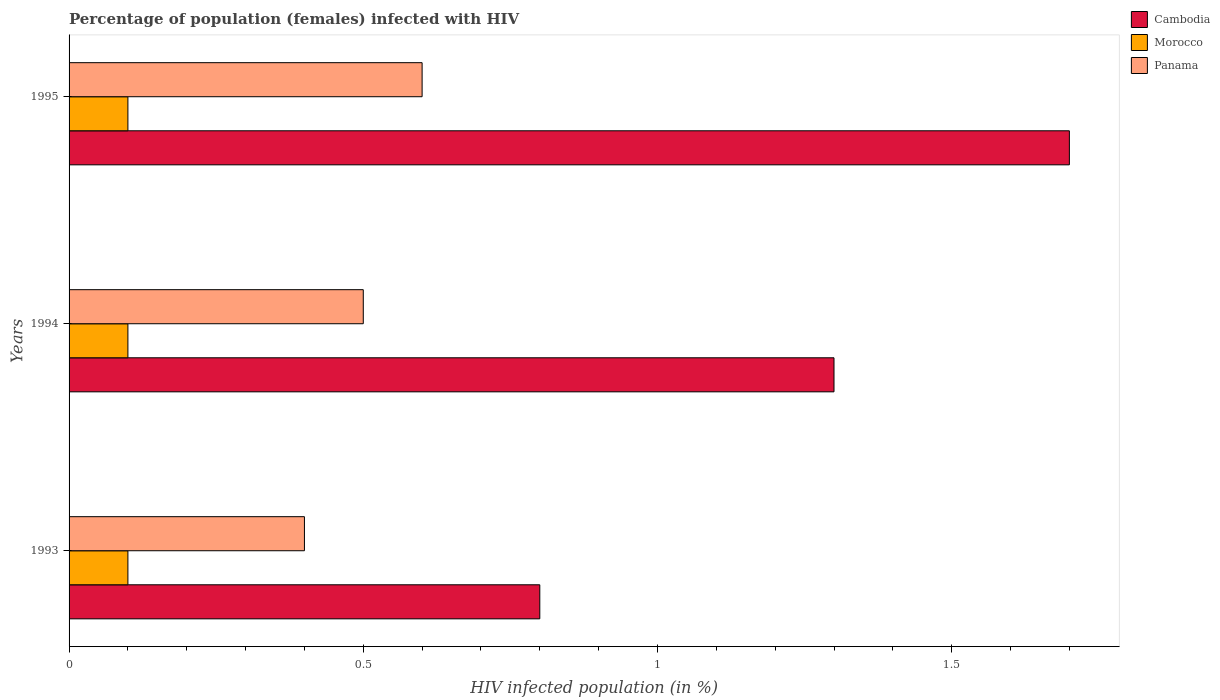How many different coloured bars are there?
Offer a very short reply. 3. Are the number of bars per tick equal to the number of legend labels?
Ensure brevity in your answer.  Yes. How many bars are there on the 2nd tick from the top?
Provide a succinct answer. 3. How many bars are there on the 2nd tick from the bottom?
Offer a terse response. 3. In which year was the percentage of HIV infected female population in Morocco maximum?
Ensure brevity in your answer.  1993. In which year was the percentage of HIV infected female population in Cambodia minimum?
Your response must be concise. 1993. What is the total percentage of HIV infected female population in Morocco in the graph?
Provide a succinct answer. 0.3. What is the difference between the percentage of HIV infected female population in Cambodia in 1993 and the percentage of HIV infected female population in Panama in 1995?
Provide a succinct answer. 0.2. What is the average percentage of HIV infected female population in Cambodia per year?
Give a very brief answer. 1.27. In the year 1994, what is the difference between the percentage of HIV infected female population in Panama and percentage of HIV infected female population in Morocco?
Offer a terse response. 0.4. In how many years, is the percentage of HIV infected female population in Cambodia greater than 0.5 %?
Give a very brief answer. 3. What is the ratio of the percentage of HIV infected female population in Cambodia in 1994 to that in 1995?
Make the answer very short. 0.76. Is the percentage of HIV infected female population in Morocco in 1993 less than that in 1994?
Keep it short and to the point. No. Is the difference between the percentage of HIV infected female population in Panama in 1993 and 1995 greater than the difference between the percentage of HIV infected female population in Morocco in 1993 and 1995?
Provide a short and direct response. No. What is the difference between the highest and the second highest percentage of HIV infected female population in Panama?
Provide a short and direct response. 0.1. What is the difference between the highest and the lowest percentage of HIV infected female population in Cambodia?
Provide a short and direct response. 0.9. Is the sum of the percentage of HIV infected female population in Panama in 1994 and 1995 greater than the maximum percentage of HIV infected female population in Cambodia across all years?
Your response must be concise. No. What does the 3rd bar from the top in 1995 represents?
Make the answer very short. Cambodia. What does the 3rd bar from the bottom in 1994 represents?
Provide a succinct answer. Panama. Is it the case that in every year, the sum of the percentage of HIV infected female population in Cambodia and percentage of HIV infected female population in Panama is greater than the percentage of HIV infected female population in Morocco?
Provide a succinct answer. Yes. What is the difference between two consecutive major ticks on the X-axis?
Your response must be concise. 0.5. Are the values on the major ticks of X-axis written in scientific E-notation?
Make the answer very short. No. Does the graph contain any zero values?
Offer a terse response. No. How many legend labels are there?
Your answer should be very brief. 3. What is the title of the graph?
Make the answer very short. Percentage of population (females) infected with HIV. Does "Bangladesh" appear as one of the legend labels in the graph?
Provide a short and direct response. No. What is the label or title of the X-axis?
Provide a short and direct response. HIV infected population (in %). What is the label or title of the Y-axis?
Your answer should be very brief. Years. What is the HIV infected population (in %) in Morocco in 1993?
Keep it short and to the point. 0.1. What is the HIV infected population (in %) in Cambodia in 1994?
Provide a short and direct response. 1.3. What is the HIV infected population (in %) of Panama in 1994?
Offer a terse response. 0.5. What is the HIV infected population (in %) in Panama in 1995?
Your answer should be very brief. 0.6. Across all years, what is the maximum HIV infected population (in %) of Cambodia?
Keep it short and to the point. 1.7. Across all years, what is the minimum HIV infected population (in %) of Cambodia?
Your answer should be very brief. 0.8. Across all years, what is the minimum HIV infected population (in %) of Morocco?
Provide a succinct answer. 0.1. What is the total HIV infected population (in %) in Cambodia in the graph?
Your answer should be compact. 3.8. What is the difference between the HIV infected population (in %) of Cambodia in 1993 and that in 1994?
Keep it short and to the point. -0.5. What is the difference between the HIV infected population (in %) of Panama in 1993 and that in 1995?
Give a very brief answer. -0.2. What is the difference between the HIV infected population (in %) in Morocco in 1994 and that in 1995?
Your response must be concise. 0. What is the difference between the HIV infected population (in %) in Panama in 1994 and that in 1995?
Offer a very short reply. -0.1. What is the difference between the HIV infected population (in %) in Cambodia in 1993 and the HIV infected population (in %) in Panama in 1995?
Provide a succinct answer. 0.2. What is the difference between the HIV infected population (in %) in Morocco in 1993 and the HIV infected population (in %) in Panama in 1995?
Keep it short and to the point. -0.5. What is the difference between the HIV infected population (in %) of Cambodia in 1994 and the HIV infected population (in %) of Morocco in 1995?
Provide a short and direct response. 1.2. What is the average HIV infected population (in %) in Cambodia per year?
Make the answer very short. 1.27. What is the average HIV infected population (in %) in Morocco per year?
Make the answer very short. 0.1. What is the average HIV infected population (in %) in Panama per year?
Give a very brief answer. 0.5. In the year 1993, what is the difference between the HIV infected population (in %) in Morocco and HIV infected population (in %) in Panama?
Offer a very short reply. -0.3. In the year 1995, what is the difference between the HIV infected population (in %) in Cambodia and HIV infected population (in %) in Panama?
Offer a terse response. 1.1. What is the ratio of the HIV infected population (in %) in Cambodia in 1993 to that in 1994?
Make the answer very short. 0.62. What is the ratio of the HIV infected population (in %) of Morocco in 1993 to that in 1994?
Make the answer very short. 1. What is the ratio of the HIV infected population (in %) in Panama in 1993 to that in 1994?
Make the answer very short. 0.8. What is the ratio of the HIV infected population (in %) of Cambodia in 1993 to that in 1995?
Your answer should be very brief. 0.47. What is the ratio of the HIV infected population (in %) of Morocco in 1993 to that in 1995?
Offer a very short reply. 1. What is the ratio of the HIV infected population (in %) in Panama in 1993 to that in 1995?
Make the answer very short. 0.67. What is the ratio of the HIV infected population (in %) of Cambodia in 1994 to that in 1995?
Offer a very short reply. 0.76. What is the ratio of the HIV infected population (in %) of Panama in 1994 to that in 1995?
Provide a succinct answer. 0.83. What is the difference between the highest and the second highest HIV infected population (in %) in Cambodia?
Offer a terse response. 0.4. What is the difference between the highest and the second highest HIV infected population (in %) in Morocco?
Provide a short and direct response. 0. What is the difference between the highest and the lowest HIV infected population (in %) of Panama?
Ensure brevity in your answer.  0.2. 